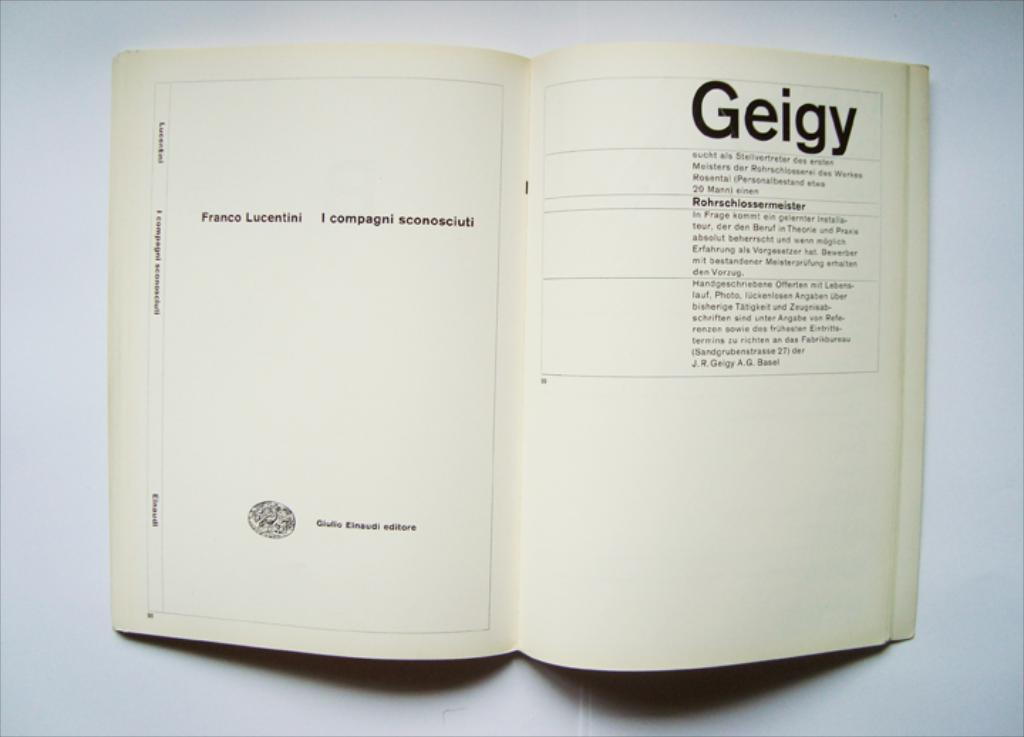<image>
Give a short and clear explanation of the subsequent image. a book that is open to a page that says 'geigy' on the top of it 